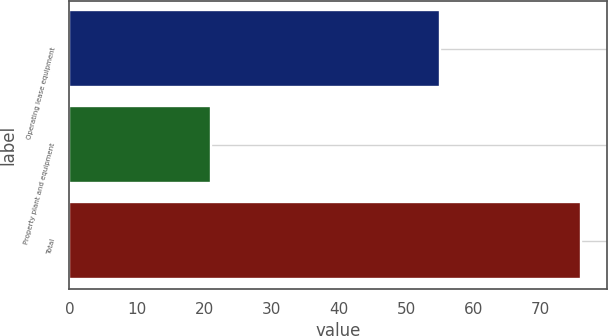<chart> <loc_0><loc_0><loc_500><loc_500><bar_chart><fcel>Operating lease equipment<fcel>Property plant and equipment<fcel>Total<nl><fcel>55<fcel>21<fcel>76<nl></chart> 